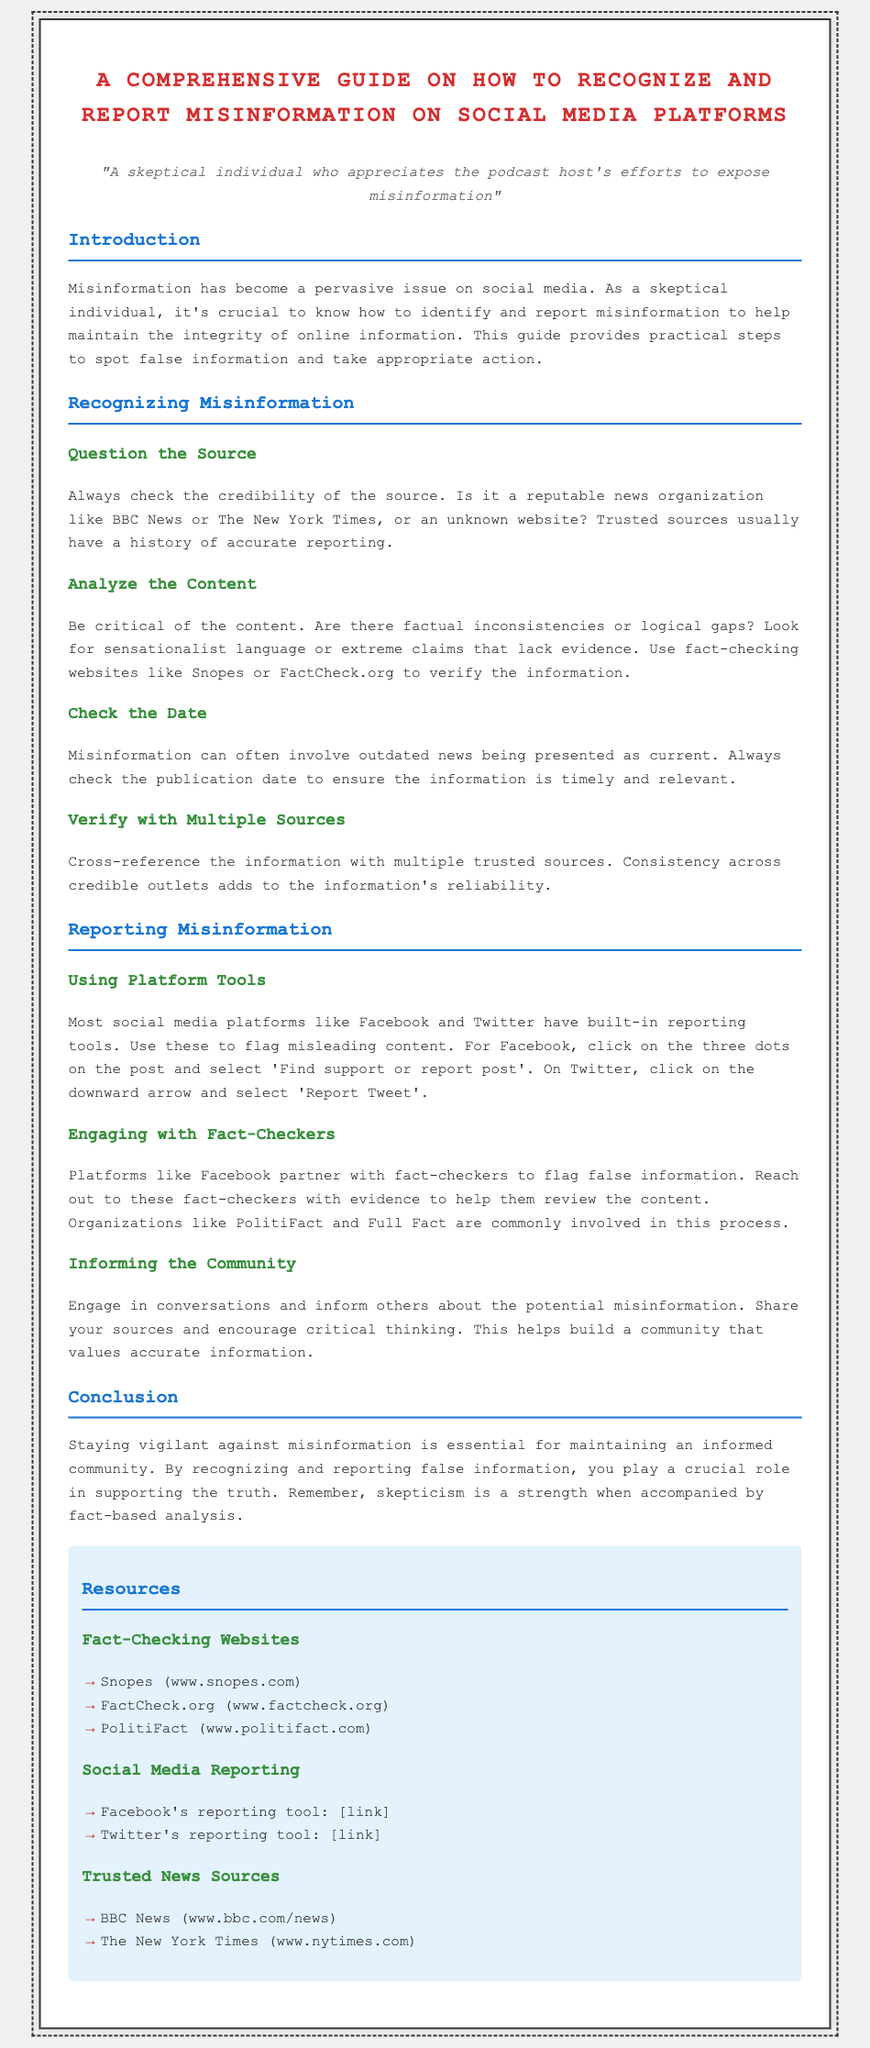What is the title of the document? The title is prominently displayed at the top of the document and provides the main subject.
Answer: A Comprehensive Guide on How to Recognize and Report Misinformation on Social Media Platforms What is the name of one fact-checking website mentioned? The document lists several fact-checking websites under the resources section.
Answer: Snopes How should you report misinformation on Facebook? The document specifies the steps to report misleading content on Facebook.
Answer: Click on the three dots and select 'Find support or report post' What is the importance of checking the date of the information? The guide explains that outdated news can be misleading and should be verified for timeliness.
Answer: To ensure the information is timely and relevant What type of language should be questioned in content analysis? The document points out specific characteristics of misinformation, including the use of certain types of language.
Answer: Sensationalist language 